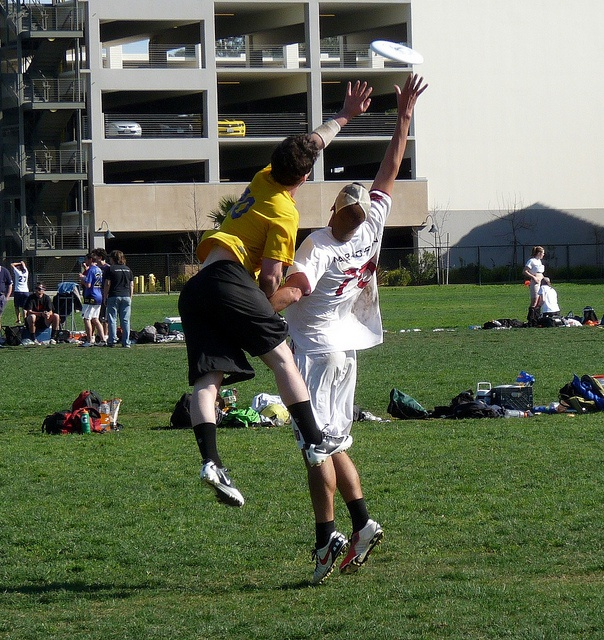Describe the objects in this image and their specific colors. I can see people in black, white, gray, and darkgray tones, people in black, maroon, gray, and olive tones, people in black, navy, gray, and darkgray tones, people in black, gray, navy, and darkgray tones, and backpack in black, navy, gray, and darkgreen tones in this image. 